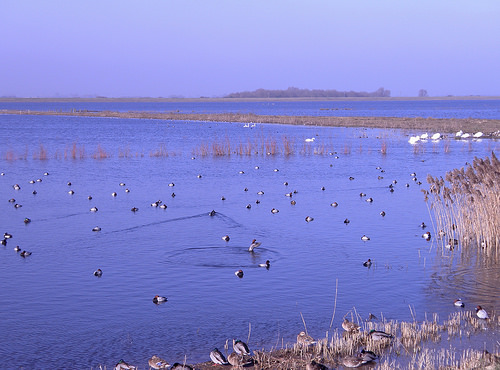<image>
Is the duck in the water? Yes. The duck is contained within or inside the water, showing a containment relationship. Is the bird above the water? No. The bird is not positioned above the water. The vertical arrangement shows a different relationship. 